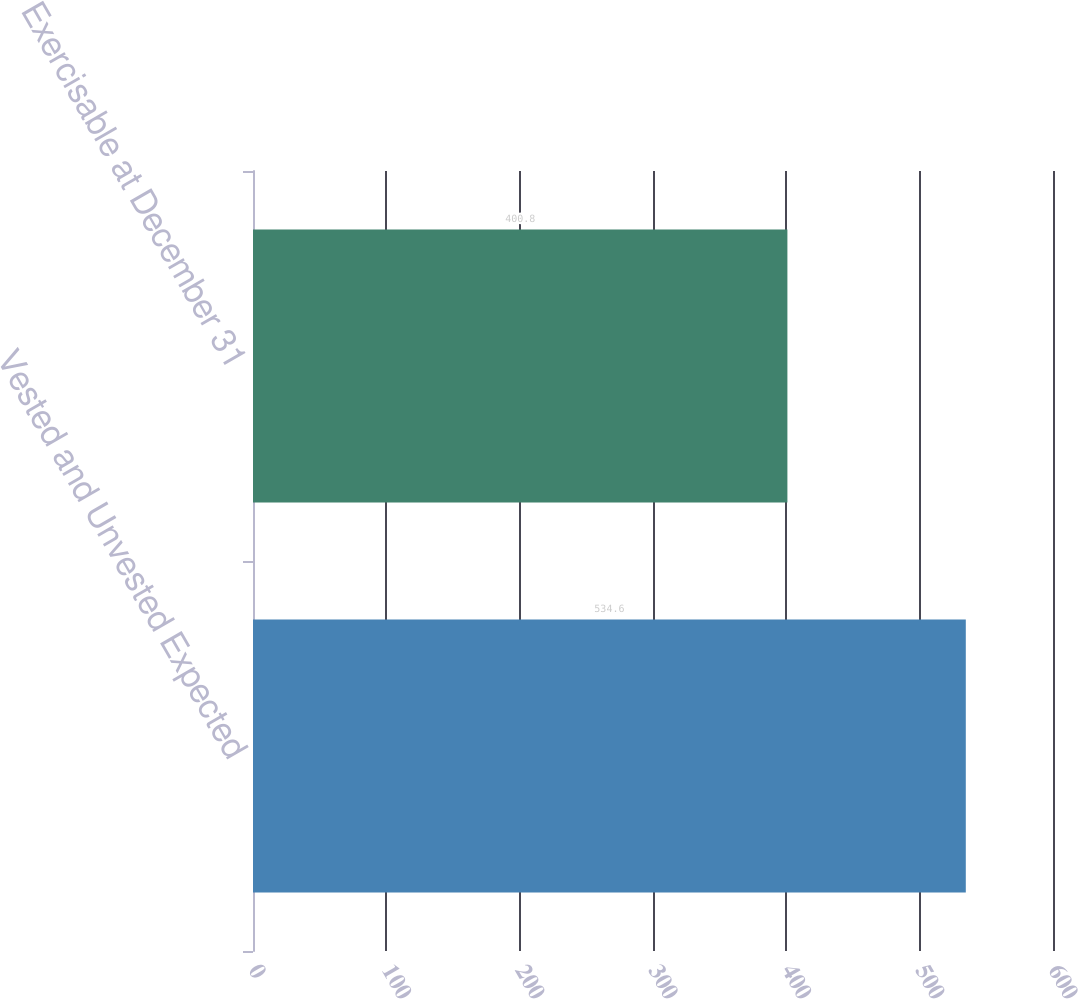Convert chart to OTSL. <chart><loc_0><loc_0><loc_500><loc_500><bar_chart><fcel>Vested and Unvested Expected<fcel>Exercisable at December 31<nl><fcel>534.6<fcel>400.8<nl></chart> 